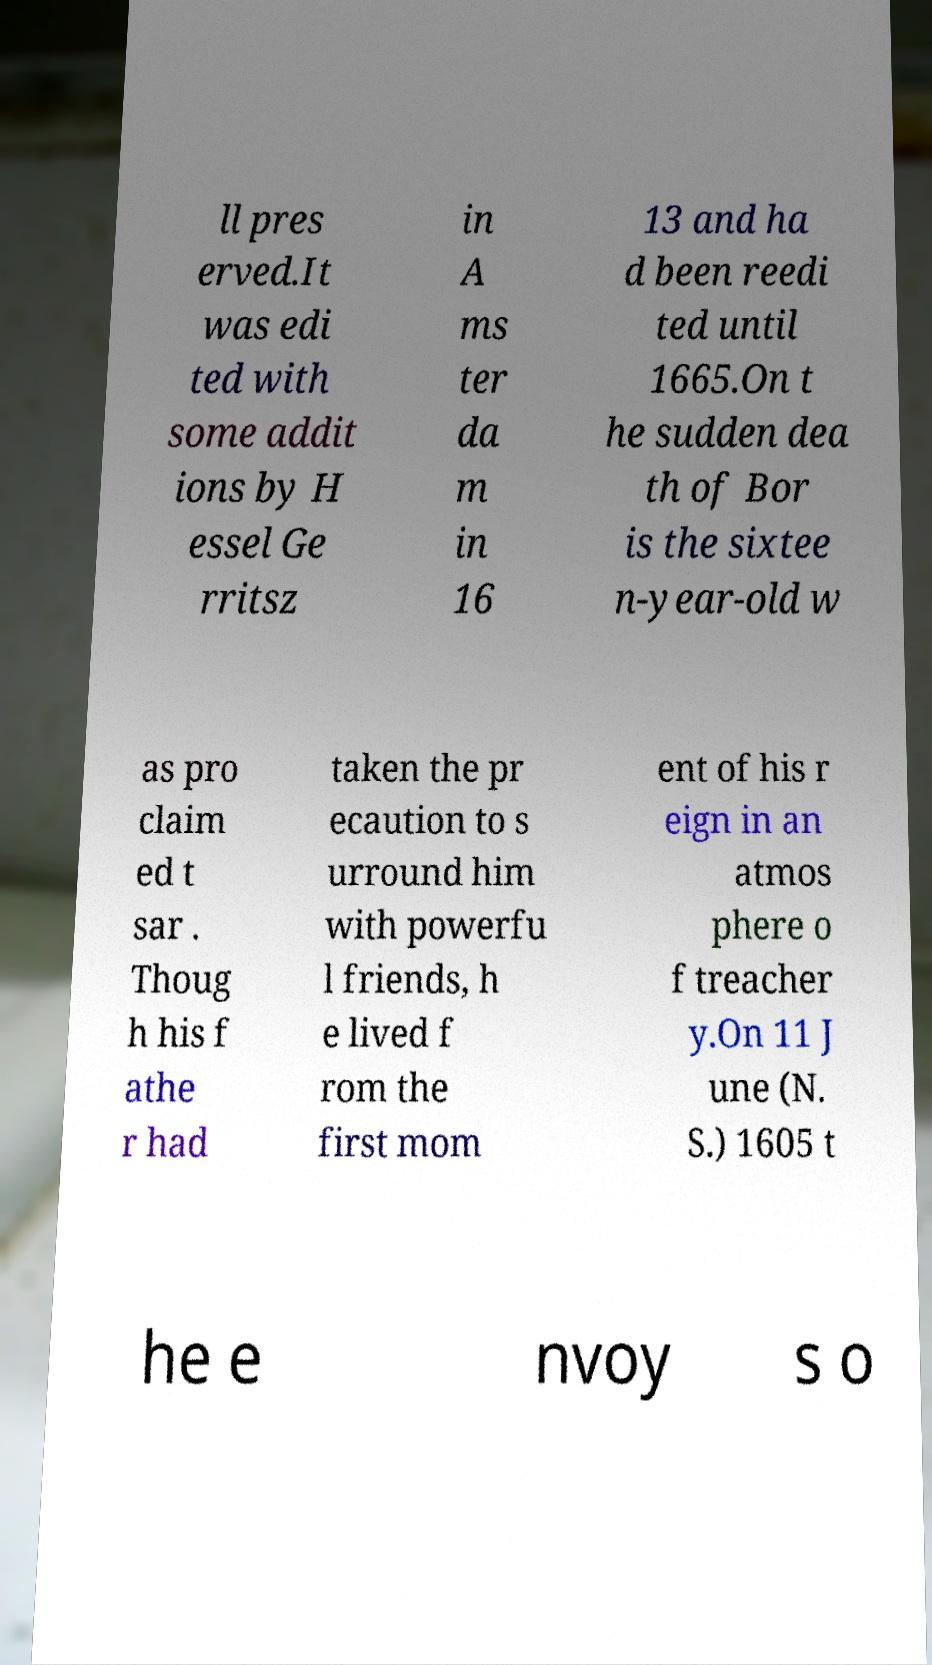Could you extract and type out the text from this image? ll pres erved.It was edi ted with some addit ions by H essel Ge rritsz in A ms ter da m in 16 13 and ha d been reedi ted until 1665.On t he sudden dea th of Bor is the sixtee n-year-old w as pro claim ed t sar . Thoug h his f athe r had taken the pr ecaution to s urround him with powerfu l friends, h e lived f rom the first mom ent of his r eign in an atmos phere o f treacher y.On 11 J une (N. S.) 1605 t he e nvoy s o 